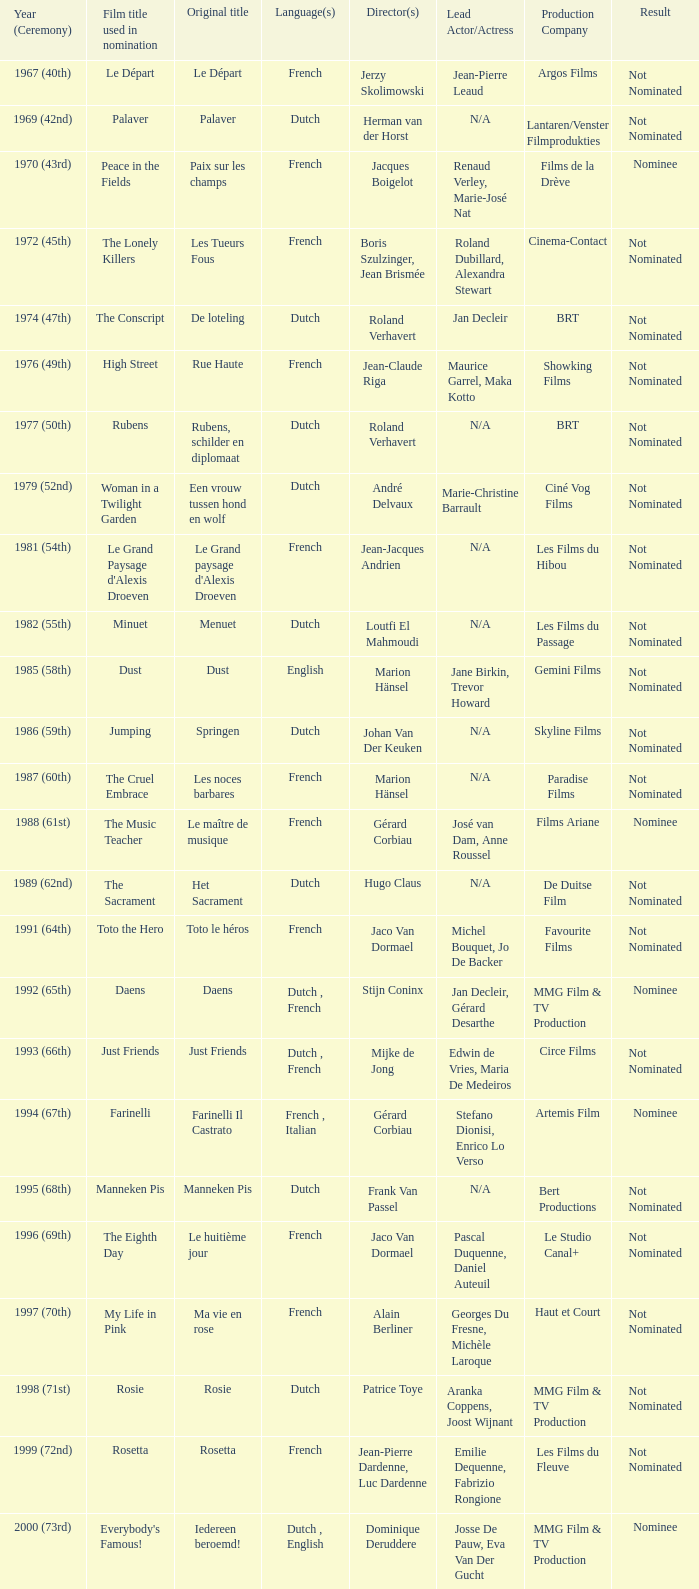What was the title used for Rosie, the film nominated for the dutch language? Rosie. 